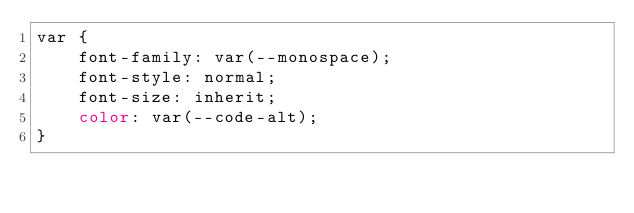Convert code to text. <code><loc_0><loc_0><loc_500><loc_500><_CSS_>var {
    font-family: var(--monospace);
    font-style: normal;
    font-size: inherit;
    color: var(--code-alt);
}</code> 